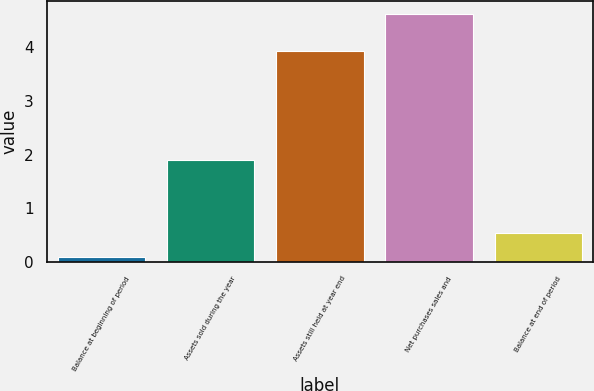Convert chart to OTSL. <chart><loc_0><loc_0><loc_500><loc_500><bar_chart><fcel>Balance at beginning of period<fcel>Assets sold during the year<fcel>Assets still held at year end<fcel>Net purchases sales and<fcel>Balance at end of period<nl><fcel>0.1<fcel>1.9<fcel>3.93<fcel>4.62<fcel>0.55<nl></chart> 